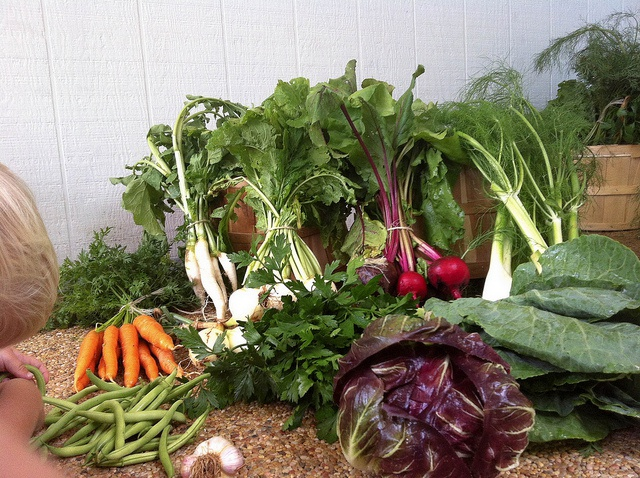Describe the objects in this image and their specific colors. I can see people in white, brown, tan, and salmon tones, carrot in white, red, orange, and brown tones, and carrot in white, orange, red, and gold tones in this image. 